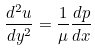<formula> <loc_0><loc_0><loc_500><loc_500>\frac { d ^ { 2 } u } { d y ^ { 2 } } = \frac { 1 } { \mu } \frac { d p } { d x }</formula> 